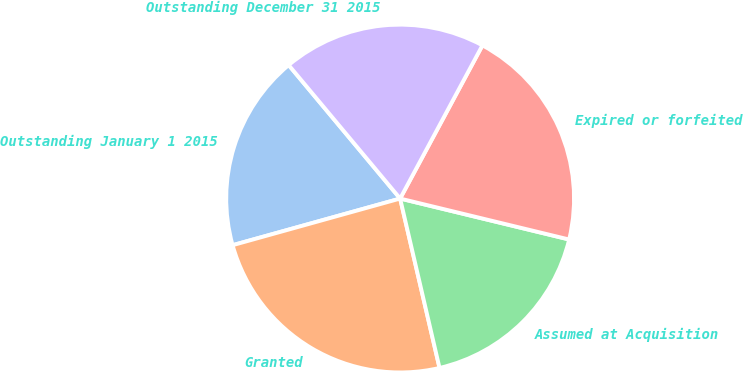Convert chart. <chart><loc_0><loc_0><loc_500><loc_500><pie_chart><fcel>Outstanding January 1 2015<fcel>Granted<fcel>Assumed at Acquisition<fcel>Expired or forfeited<fcel>Outstanding December 31 2015<nl><fcel>18.25%<fcel>24.32%<fcel>17.58%<fcel>20.94%<fcel>18.92%<nl></chart> 